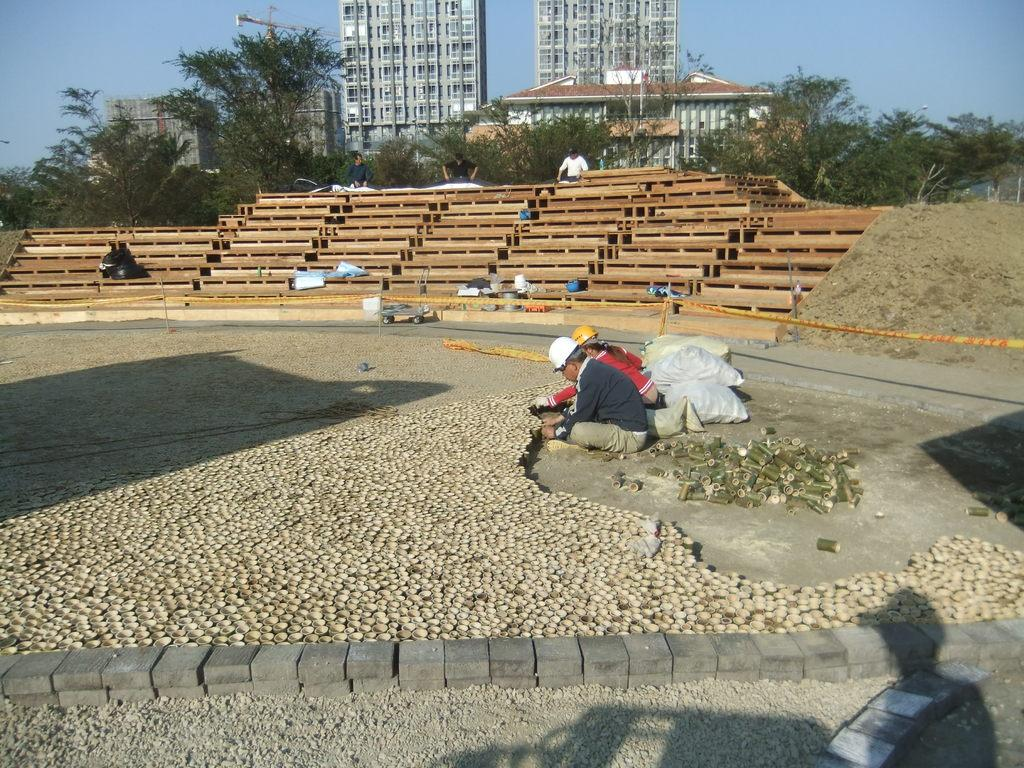How many people are in the image? There is a group of people in the image. What type of seating is present in the image? There are benches in the image. What type of structures can be seen in the image? There are buildings in the image. What type of vegetation is present in the image? There are trees in the image. What type of objects are on the floor in the image? There are objects on the floor in the image. What is visible in the background of the image? The sky is visible in the background of the image. What color is the blood on the hydrant in the image? There is no hydrant or blood present in the image. Is there a prison visible in the image? There is no prison present in the image. 